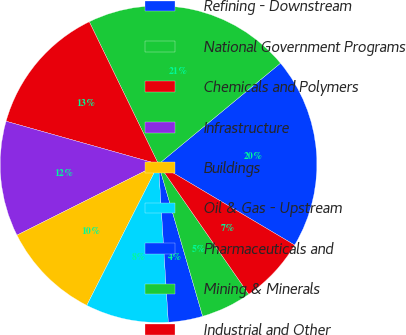<chart> <loc_0><loc_0><loc_500><loc_500><pie_chart><fcel>Refining - Downstream<fcel>National Government Programs<fcel>Chemicals and Polymers<fcel>Infrastructure<fcel>Buildings<fcel>Oil & Gas - Upstream<fcel>Pharmaceuticals and<fcel>Mining & Minerals<fcel>Industrial and Other<nl><fcel>19.54%<fcel>21.2%<fcel>13.43%<fcel>11.77%<fcel>10.12%<fcel>8.47%<fcel>3.51%<fcel>5.16%<fcel>6.81%<nl></chart> 